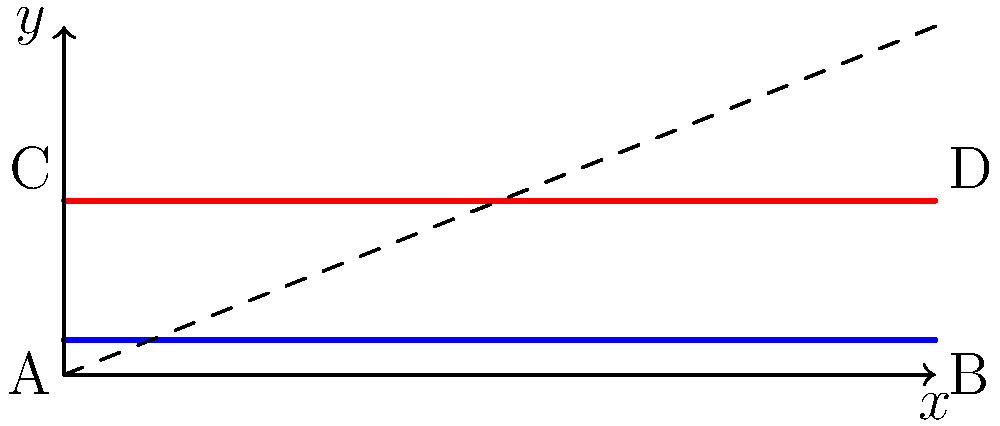In the upper half-plane model of hyperbolic geometry, consider two horizontal lines: one at $y=0.2$ (blue) and another at $y=1$ (red). Points A and B lie on the blue line, while points C and D lie on the red line. All four points have the same $x$-coordinates pairwise (A with C, and B with D). Which pair of points, AB or CD, has a greater hyperbolic distance between them, and why? To solve this problem, we need to understand how distances are calculated in the upper half-plane model of hyperbolic geometry:

1. In the upper half-plane model, the metric is given by:
   $$ds^2 = \frac{dx^2 + dy^2}{y^2}$$

2. For horizontal lines (where $dy = 0$), the hyperbolic distance between two points $(x_1, y)$ and $(x_2, y)$ is:
   $$d = \int_{x_1}^{x_2} \frac{dx}{y} = \frac{1}{y}|x_2 - x_1|$$

3. For the blue line (AB), $y = 0.2$, so the distance is:
   $$d_{AB} = \frac{1}{0.2}|x_B - x_A| = 5|x_B - x_A|$$

4. For the red line (CD), $y = 1$, so the distance is:
   $$d_{CD} = \frac{1}{1}|x_D - x_C| = |x_D - x_C|$$

5. Since the $x$-coordinates are the same for both pairs (A with C, and B with D), we have:
   $$|x_B - x_A| = |x_D - x_C|$$

6. Comparing the distances:
   $$d_{AB} = 5|x_B - x_A| > |x_D - x_C| = d_{CD}$$

Therefore, the hyperbolic distance between A and B is greater than the hyperbolic distance between C and D, even though they have the same Euclidean distance.
Answer: AB has a greater hyperbolic distance because it's closer to the $x$-axis, where the hyperbolic metric stretches distances more. 